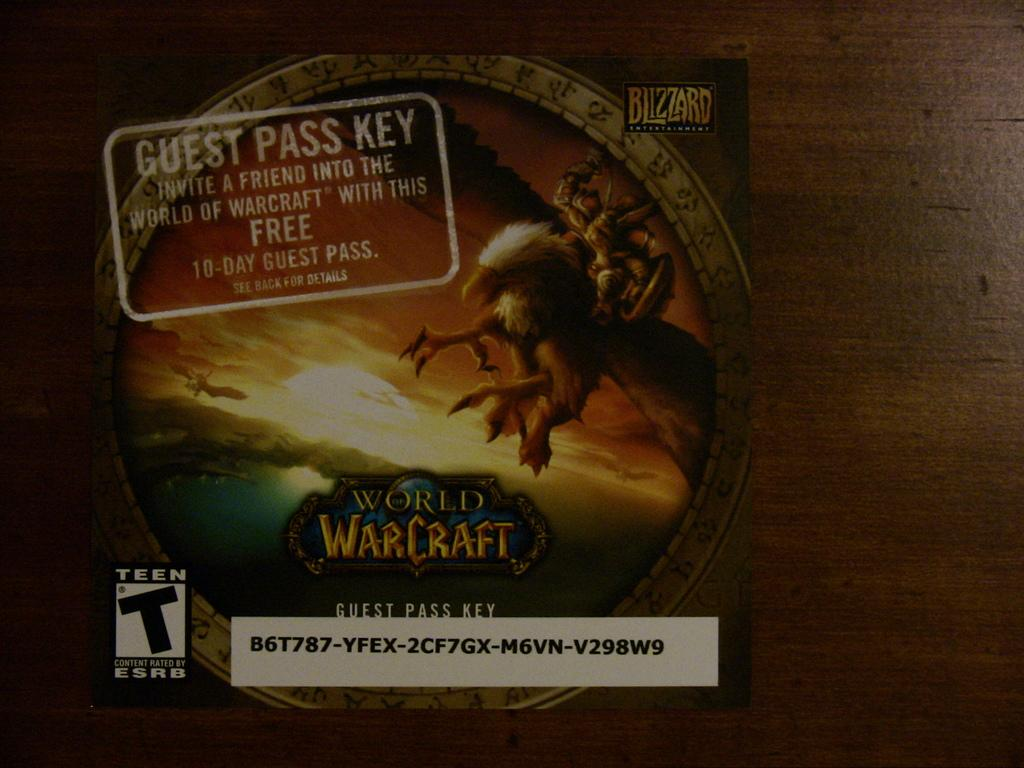Provide a one-sentence caption for the provided image. A guest pass key for World of Warcraft. 